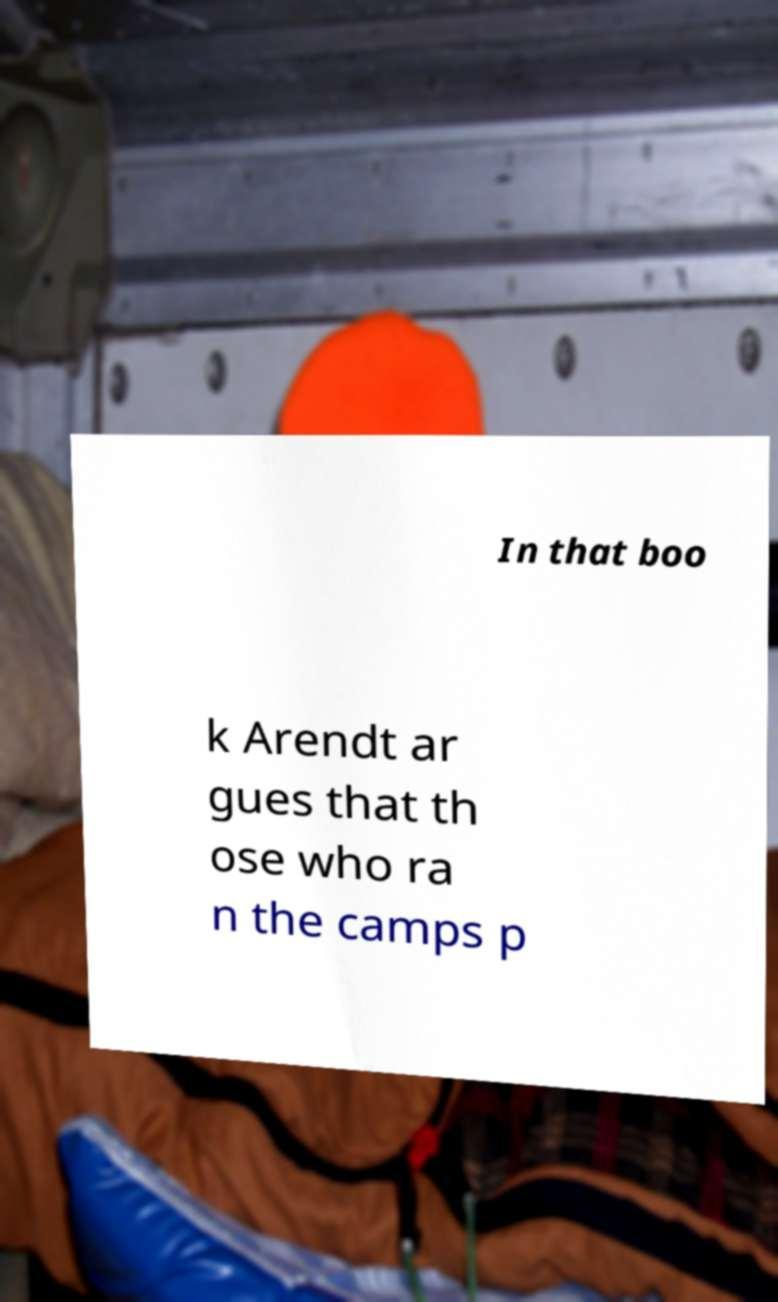I need the written content from this picture converted into text. Can you do that? In that boo k Arendt ar gues that th ose who ra n the camps p 